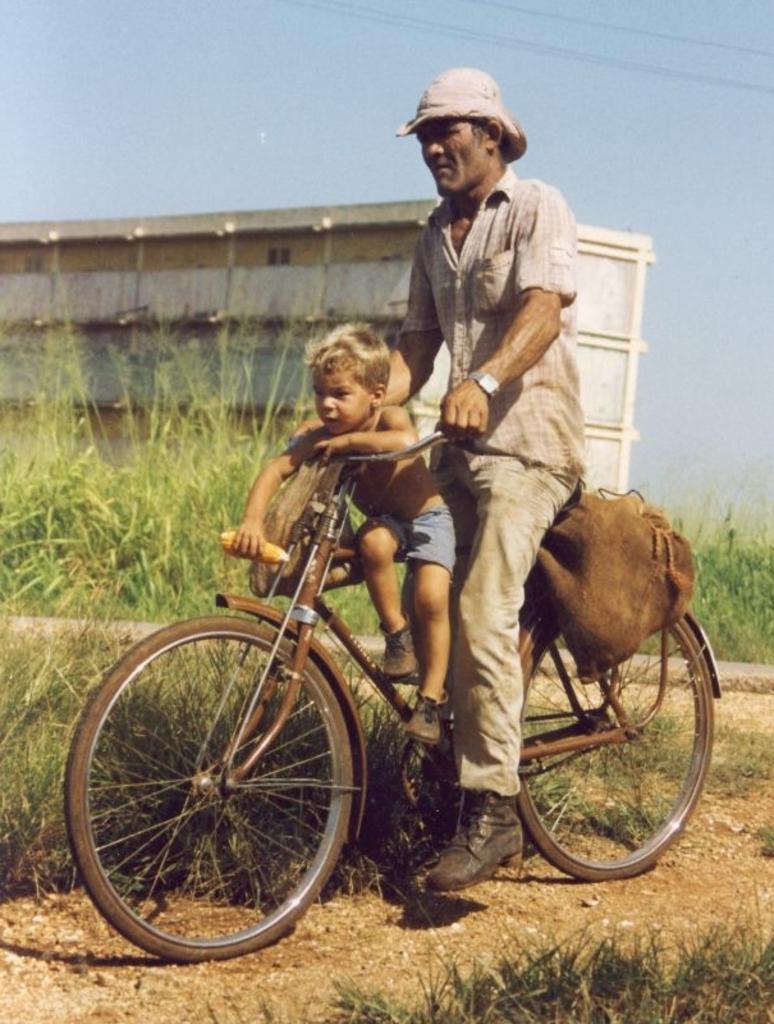Describe this image in one or two sentences. In this picture we can see man riding bicycle and boy is sitting on bicycle holding corn in one hand and in background we can see trees, building, sky, wires. 